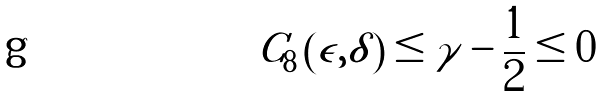Convert formula to latex. <formula><loc_0><loc_0><loc_500><loc_500>C _ { 8 } \left ( \epsilon , \delta \right ) \leq \gamma - \frac { 1 } { 2 } \leq 0</formula> 